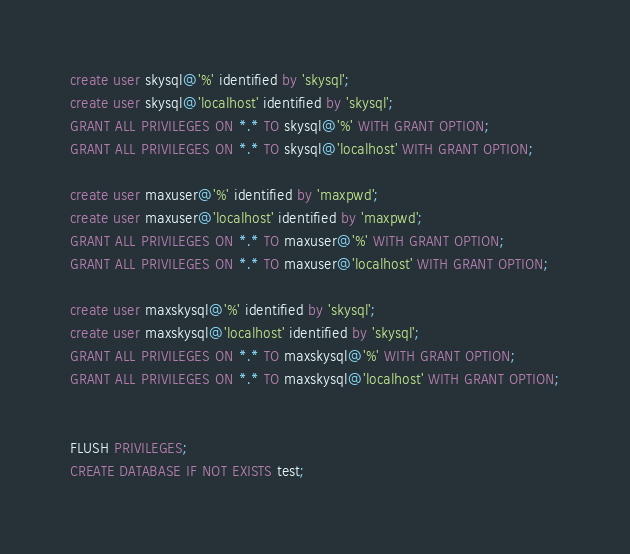Convert code to text. <code><loc_0><loc_0><loc_500><loc_500><_SQL_>create user skysql@'%' identified by 'skysql';
create user skysql@'localhost' identified by 'skysql';
GRANT ALL PRIVILEGES ON *.* TO skysql@'%' WITH GRANT OPTION;
GRANT ALL PRIVILEGES ON *.* TO skysql@'localhost' WITH GRANT OPTION;

create user maxuser@'%' identified by 'maxpwd';
create user maxuser@'localhost' identified by 'maxpwd';
GRANT ALL PRIVILEGES ON *.* TO maxuser@'%' WITH GRANT OPTION;
GRANT ALL PRIVILEGES ON *.* TO maxuser@'localhost' WITH GRANT OPTION;

create user maxskysql@'%' identified by 'skysql';
create user maxskysql@'localhost' identified by 'skysql';
GRANT ALL PRIVILEGES ON *.* TO maxskysql@'%' WITH GRANT OPTION;
GRANT ALL PRIVILEGES ON *.* TO maxskysql@'localhost' WITH GRANT OPTION;


FLUSH PRIVILEGES;
CREATE DATABASE IF NOT EXISTS test;
</code> 